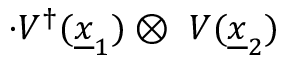Convert formula to latex. <formula><loc_0><loc_0><loc_500><loc_500>\cdot V ^ { \dagger } ( { \underline { x } } _ { 1 } ) \otimes \ V ( { \underline { x } } _ { 2 } )</formula> 